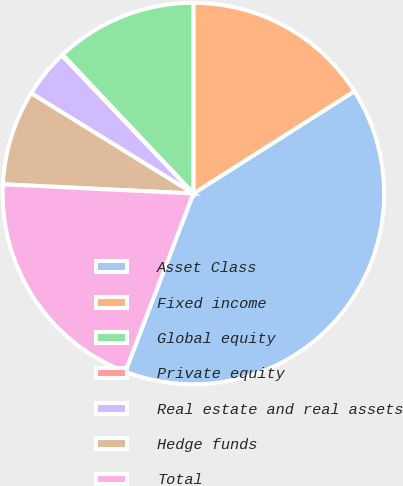<chart> <loc_0><loc_0><loc_500><loc_500><pie_chart><fcel>Asset Class<fcel>Fixed income<fcel>Global equity<fcel>Private equity<fcel>Real estate and real assets<fcel>Hedge funds<fcel>Total<nl><fcel>39.82%<fcel>15.99%<fcel>12.02%<fcel>0.1%<fcel>4.07%<fcel>8.04%<fcel>19.96%<nl></chart> 